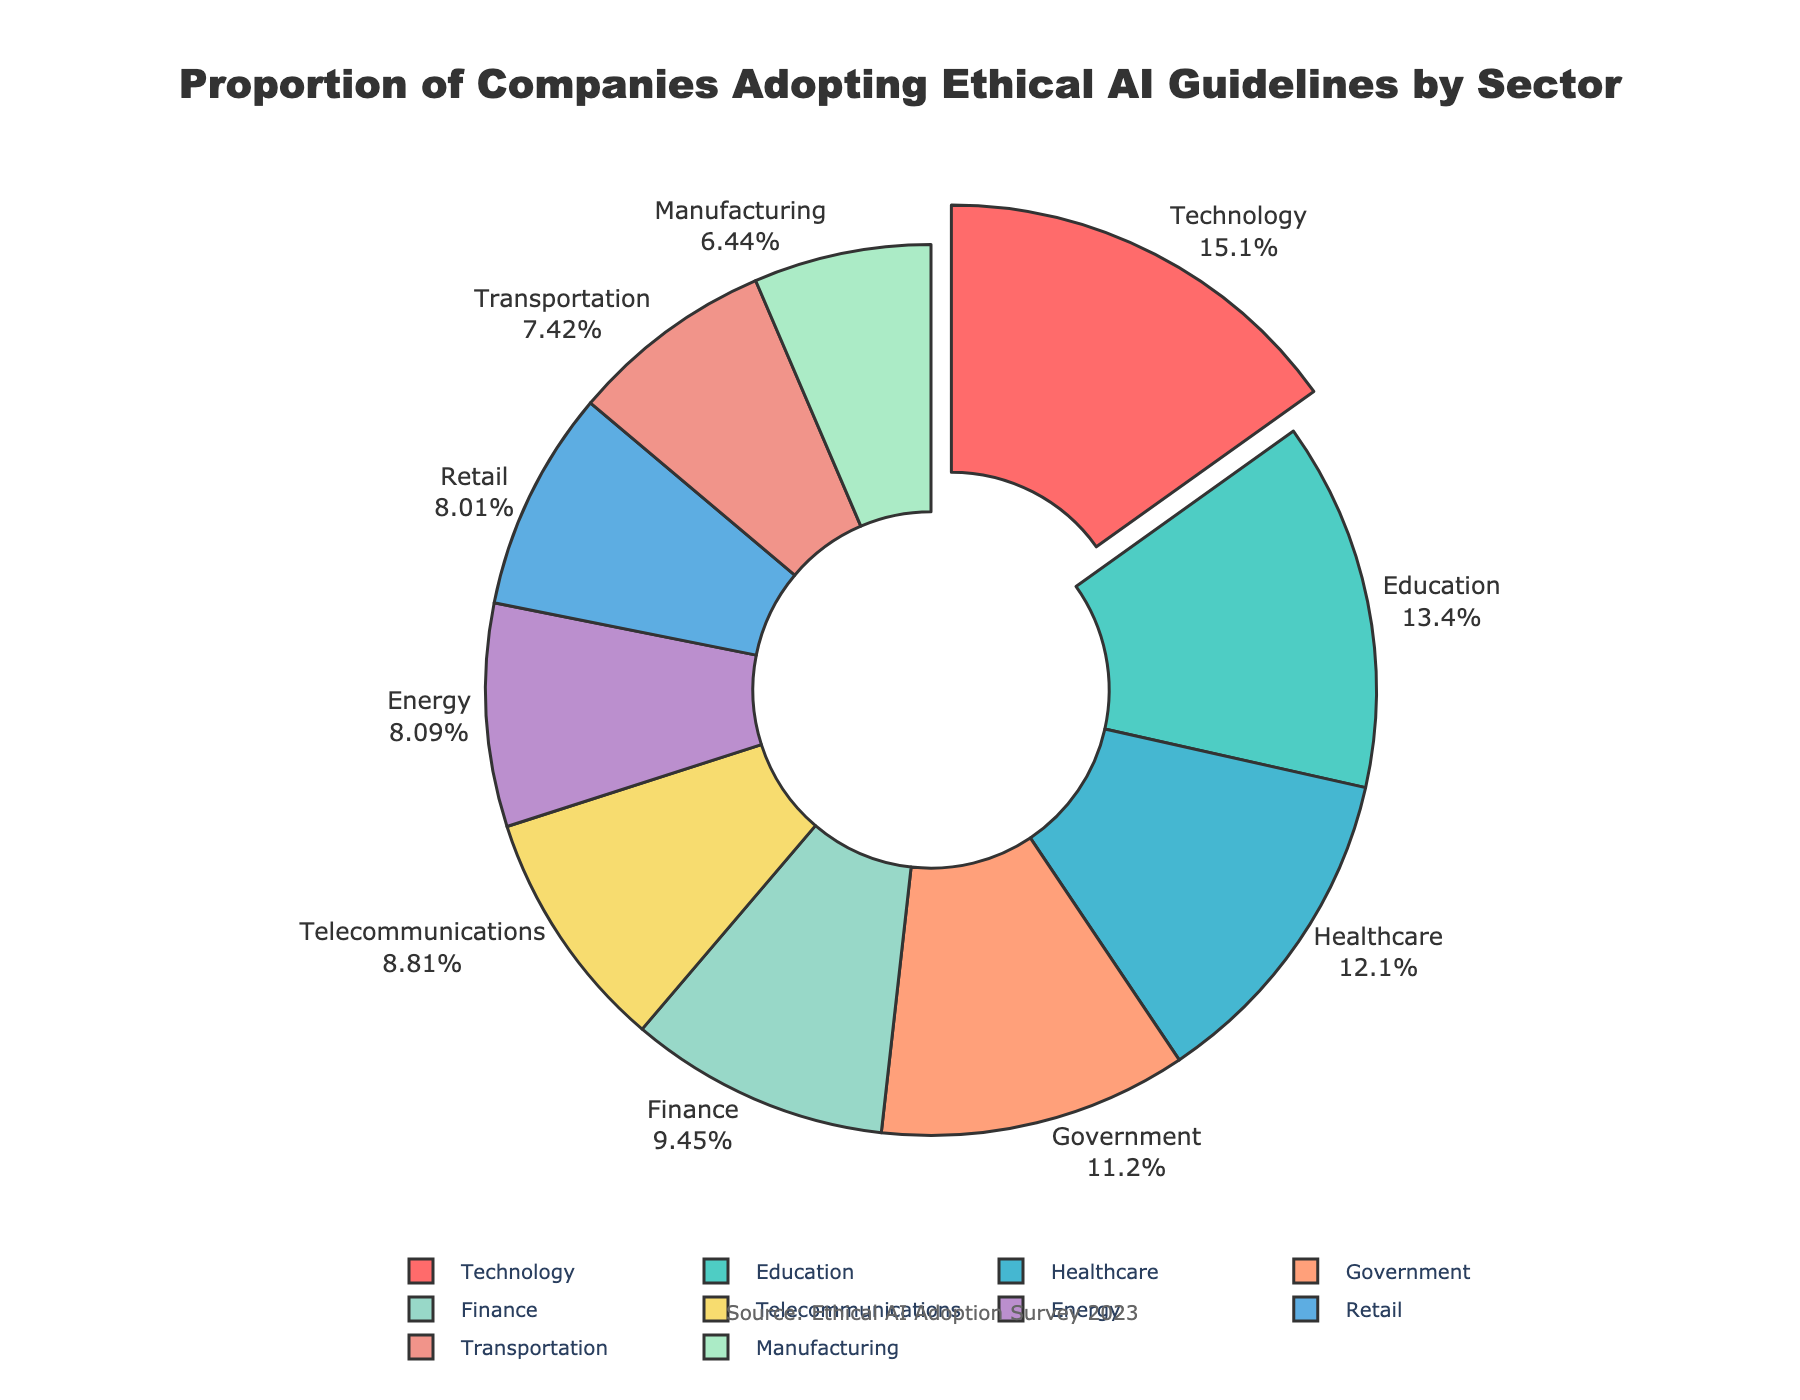Which sector has the highest proportion of companies adopting ethical AI guidelines? The sector with the highest proportion can be determined by looking at the largest slice of the pie chart. In this case, the Technology sector has the largest slice.
Answer: Technology Which two sectors together account for the largest percentage of companies adopting ethical AI guidelines? First, identify the sectors with the highest percentages. Technology (35.7%) and Education (31.6%) are the top two. Adding these up gives 35.7% + 31.6% = 67.3%.
Answer: Technology and Education Which sector has more companies adopting ethical AI guidelines, Finance or Energy? Compare the percentages for Finance (22.3%) and Energy (19.1%). The Finance sector has a higher percentage.
Answer: Finance How does the proportion of companies in the Healthcare sector adopting ethical AI guidelines compare to those in the Government sector? The Healthcare sector has 28.5%, while the Government sector has 26.4%. The Healthcare sector has a slightly higher proportion.
Answer: Healthcare What is the combined proportion of companies in the Manufacturing, Retail, and Transportation sectors? Add the percentages of Manufacturing (15.2%), Retail (18.9%), and Transportation (17.5%). 15.2% + 18.9% + 17.5% = 51.6%.
Answer: 51.6% How much higher is the Technology sector's proportion compared to the Telecommunications sector? Subtract the percentage of Telecommunications (20.8%) from Technology (35.7%). 35.7% - 20.8% = 14.9%.
Answer: 14.9% Which sector is represented by the smallest slice in the pie chart? The smallest slice corresponds to the Manufacturing sector, with the smallest percentage of 15.2%.
Answer: Manufacturing If you combine the Government and Healthcare sectors, will their proportion exceed that of the Technology sector? The combined proportion of Government (26.4%) and Healthcare (28.5%) is 26.4% + 28.5% = 54.9%. This exceeds the Technology sector's 35.7%.
Answer: Yes What is the average percentage of companies adopting ethical AI guidelines across all sectors? Sum the percentages of all sectors: 28.5 + 22.3 + 35.7 + 15.2 + 18.9 + 31.6 + 26.4 + 20.8 + 17.5 + 19.1 = 236. The average is 236 / 10 = 23.6%.
Answer: 23.6% What color represents the Retail sector in the pie chart? Identify the color associated with the "Retail" label. The pie chart uses a specific color order, and Retail is the fifth segment, represented by a specific color (#FFA07A). In the pie chart, it translates to a light orange color.
Answer: Light Orange 